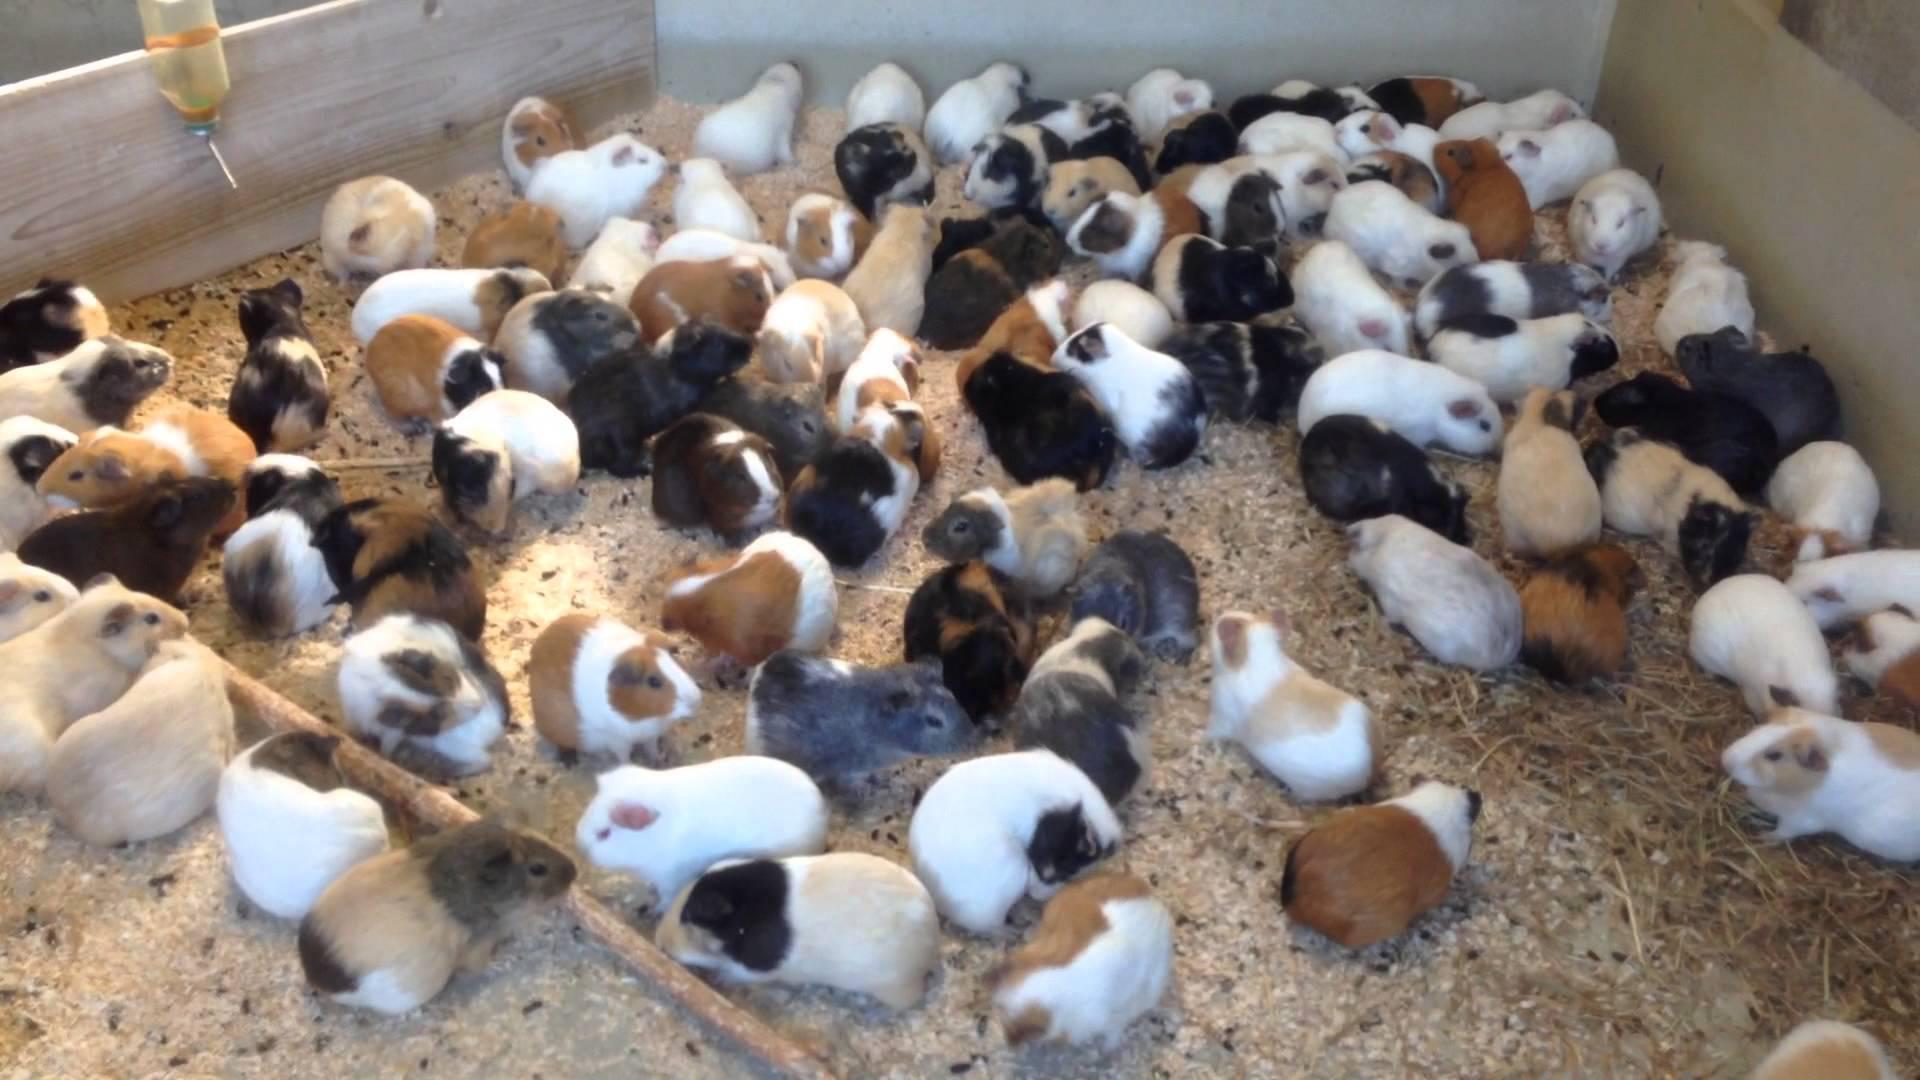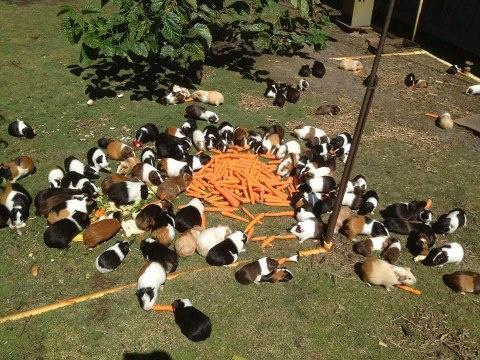The first image is the image on the left, the second image is the image on the right. Examine the images to the left and right. Is the description "Some of the animals are sitting in a grassy area in one of the images." accurate? Answer yes or no. Yes. The first image is the image on the left, the second image is the image on the right. For the images shown, is this caption "An image shows guinea pigs clustered around a pile of something that is brighter in color than the rest of the ground area." true? Answer yes or no. Yes. 